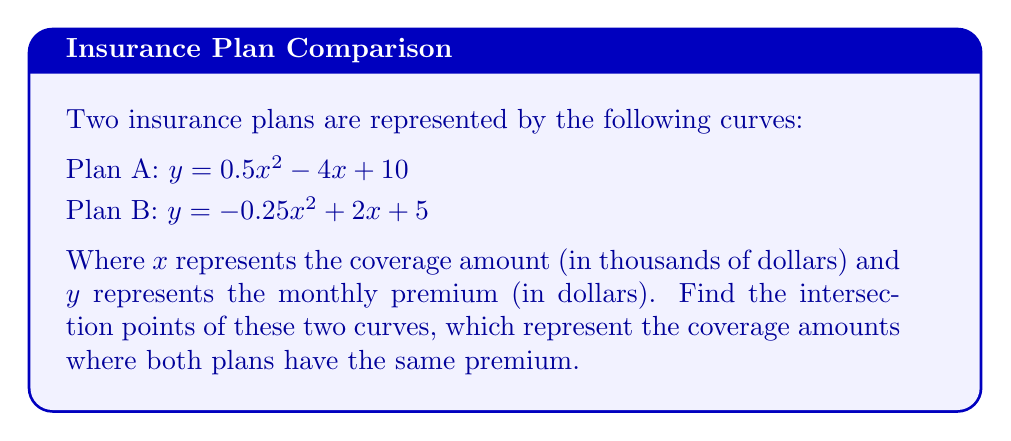Solve this math problem. To find the intersection points, we need to solve the equation where both plans have the same y-value:

1) Set the equations equal to each other:
   $0.5x^2 - 4x + 10 = -0.25x^2 + 2x + 5$

2) Rearrange all terms to one side:
   $0.5x^2 - 4x + 10 + 0.25x^2 - 2x - 5 = 0$
   $0.75x^2 - 6x + 5 = 0$

3) Multiply all terms by 4 to eliminate fractions:
   $3x^2 - 24x + 20 = 0$

4) This is a quadratic equation. We can solve it using the quadratic formula:
   $x = \frac{-b \pm \sqrt{b^2 - 4ac}}{2a}$

   Where $a = 3$, $b = -24$, and $c = 20$

5) Substituting these values:
   $x = \frac{24 \pm \sqrt{(-24)^2 - 4(3)(20)}}{2(3)}$
   $x = \frac{24 \pm \sqrt{576 - 240}}{6}$
   $x = \frac{24 \pm \sqrt{336}}{6}$
   $x = \frac{24 \pm 18.33}{6}$

6) This gives us two solutions:
   $x_1 = \frac{24 + 18.33}{6} \approx 7.06$
   $x_2 = \frac{24 - 18.33}{6} \approx 0.94$

7) To find the y-coordinates, we can substitute these x-values into either of the original equations. Let's use Plan A:

   For $x_1 = 7.06$:
   $y = 0.5(7.06)^2 - 4(7.06) + 10 \approx 10.00$

   For $x_2 = 0.94$:
   $y = 0.5(0.94)^2 - 4(0.94) + 10 \approx 6.22$

Therefore, the intersection points are approximately (7.06, 10.00) and (0.94, 6.22).
Answer: (7.06, 10.00) and (0.94, 6.22) 